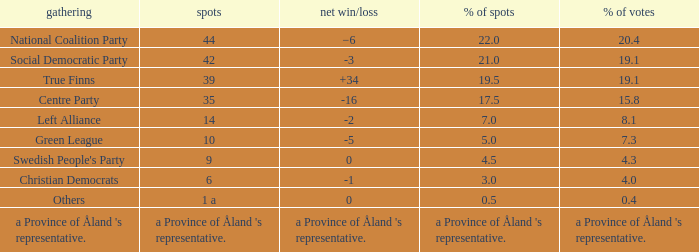When the Swedish People's Party had a net gain/loss of 0, how many seats did they have? 9.0. 